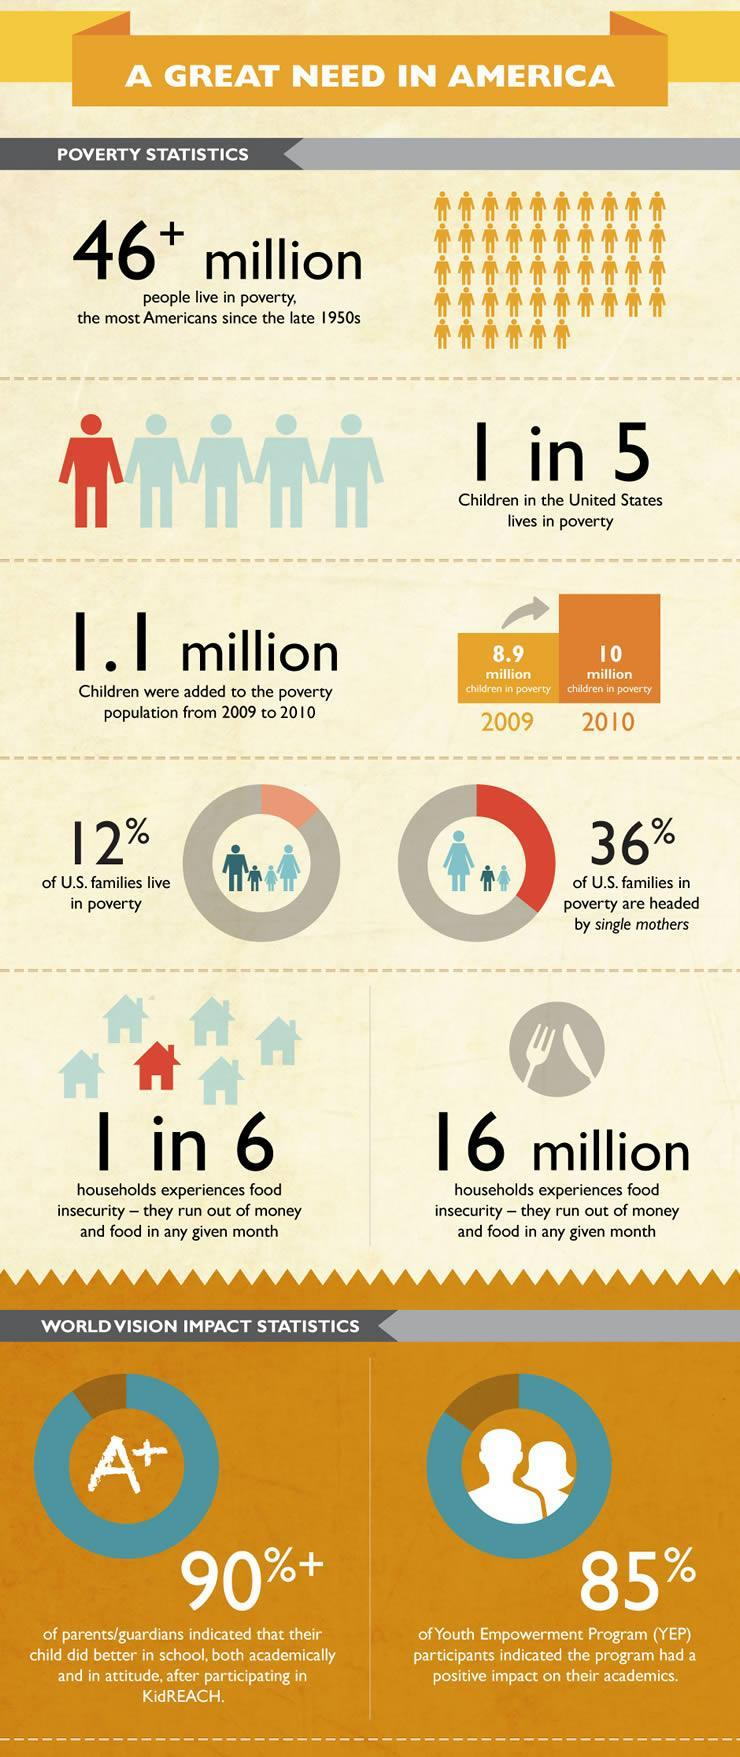What percentage of U.S. families live in poverty?
Answer the question with a short phrase. 12% What percentage of U.S. families who live in poverty are headed by single mothers?? 36% 